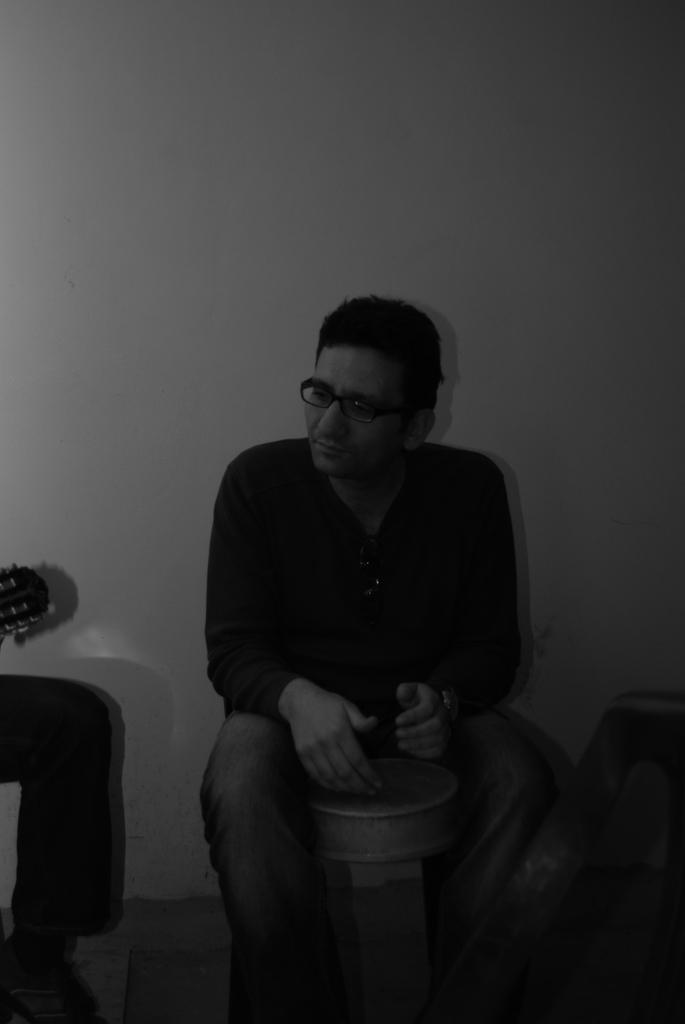What is the man in the image doing? The man is sitting in the image. Can you describe any body parts visible in the image? A person's leg is visible on the left side of the image. What can be seen in the background of the image? There is a wall in the background of the image. What type of chess move is the man making in the image? There is no chess board or pieces visible in the image, so it is not possible to determine any chess moves being made. 